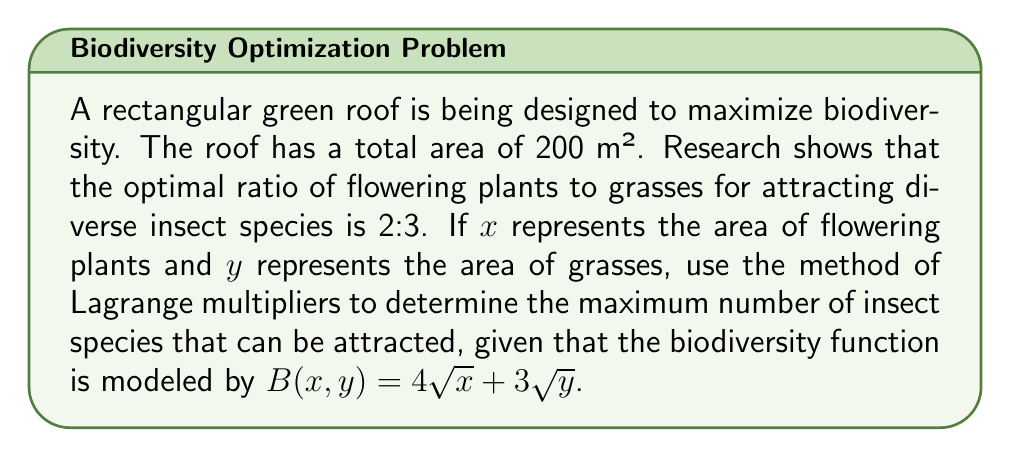Could you help me with this problem? 1) First, we set up our constraints:
   $x + y = 200$ (total area constraint)
   $\frac{x}{y} = \frac{2}{3}$ (optimal ratio constraint)

2) From the ratio constraint, we can express $x$ in terms of $y$:
   $x = \frac{2y}{3}$

3) Substituting this into the total area constraint:
   $\frac{2y}{3} + y = 200$
   $\frac{5y}{3} = 200$
   $y = 120$

4) Now we can find $x$:
   $x = \frac{2(120)}{3} = 80$

5) The Lagrange multiplier method isn't necessary here as we've found the unique solution satisfying our constraints. We can now evaluate the biodiversity function:

   $B(x,y) = 4\sqrt{x} + 3\sqrt{y}$
   $B(80,120) = 4\sqrt{80} + 3\sqrt{120}$
   $= 4(8.944) + 3(10.954)$
   $= 35.776 + 32.862$
   $= 68.638$

6) Therefore, the maximum number of insect species that can be attracted is approximately 69 (rounding up to the nearest whole number, as we can't have a fractional number of species).
Answer: 69 insect species 